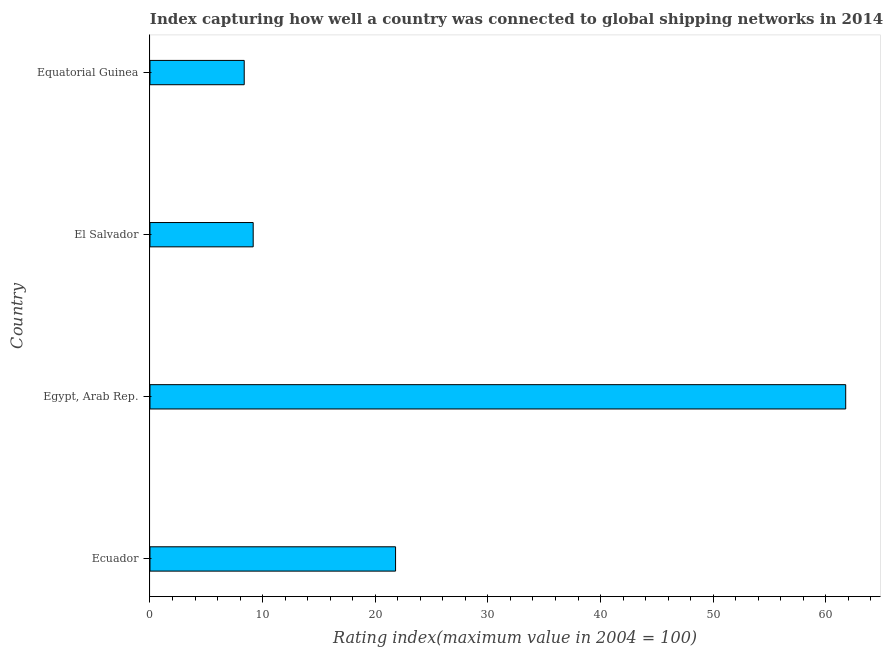What is the title of the graph?
Your response must be concise. Index capturing how well a country was connected to global shipping networks in 2014. What is the label or title of the X-axis?
Offer a very short reply. Rating index(maximum value in 2004 = 100). What is the label or title of the Y-axis?
Offer a very short reply. Country. What is the liner shipping connectivity index in El Salvador?
Provide a succinct answer. 9.16. Across all countries, what is the maximum liner shipping connectivity index?
Keep it short and to the point. 61.76. Across all countries, what is the minimum liner shipping connectivity index?
Your response must be concise. 8.36. In which country was the liner shipping connectivity index maximum?
Give a very brief answer. Egypt, Arab Rep. In which country was the liner shipping connectivity index minimum?
Keep it short and to the point. Equatorial Guinea. What is the sum of the liner shipping connectivity index?
Offer a terse response. 101.09. What is the difference between the liner shipping connectivity index in Ecuador and Egypt, Arab Rep.?
Ensure brevity in your answer.  -39.96. What is the average liner shipping connectivity index per country?
Your answer should be very brief. 25.27. What is the median liner shipping connectivity index?
Offer a very short reply. 15.48. What is the ratio of the liner shipping connectivity index in Ecuador to that in El Salvador?
Provide a succinct answer. 2.38. Is the difference between the liner shipping connectivity index in Ecuador and Equatorial Guinea greater than the difference between any two countries?
Ensure brevity in your answer.  No. What is the difference between the highest and the second highest liner shipping connectivity index?
Offer a terse response. 39.96. What is the difference between the highest and the lowest liner shipping connectivity index?
Your answer should be very brief. 53.4. In how many countries, is the liner shipping connectivity index greater than the average liner shipping connectivity index taken over all countries?
Give a very brief answer. 1. How many countries are there in the graph?
Provide a short and direct response. 4. What is the Rating index(maximum value in 2004 = 100) in Ecuador?
Offer a very short reply. 21.8. What is the Rating index(maximum value in 2004 = 100) in Egypt, Arab Rep.?
Make the answer very short. 61.76. What is the Rating index(maximum value in 2004 = 100) in El Salvador?
Your response must be concise. 9.16. What is the Rating index(maximum value in 2004 = 100) of Equatorial Guinea?
Provide a succinct answer. 8.36. What is the difference between the Rating index(maximum value in 2004 = 100) in Ecuador and Egypt, Arab Rep.?
Ensure brevity in your answer.  -39.96. What is the difference between the Rating index(maximum value in 2004 = 100) in Ecuador and El Salvador?
Your response must be concise. 12.64. What is the difference between the Rating index(maximum value in 2004 = 100) in Ecuador and Equatorial Guinea?
Offer a very short reply. 13.44. What is the difference between the Rating index(maximum value in 2004 = 100) in Egypt, Arab Rep. and El Salvador?
Ensure brevity in your answer.  52.6. What is the difference between the Rating index(maximum value in 2004 = 100) in Egypt, Arab Rep. and Equatorial Guinea?
Offer a very short reply. 53.4. What is the difference between the Rating index(maximum value in 2004 = 100) in El Salvador and Equatorial Guinea?
Provide a short and direct response. 0.8. What is the ratio of the Rating index(maximum value in 2004 = 100) in Ecuador to that in Egypt, Arab Rep.?
Provide a short and direct response. 0.35. What is the ratio of the Rating index(maximum value in 2004 = 100) in Ecuador to that in El Salvador?
Provide a succinct answer. 2.38. What is the ratio of the Rating index(maximum value in 2004 = 100) in Ecuador to that in Equatorial Guinea?
Ensure brevity in your answer.  2.61. What is the ratio of the Rating index(maximum value in 2004 = 100) in Egypt, Arab Rep. to that in El Salvador?
Make the answer very short. 6.74. What is the ratio of the Rating index(maximum value in 2004 = 100) in Egypt, Arab Rep. to that in Equatorial Guinea?
Keep it short and to the point. 7.38. What is the ratio of the Rating index(maximum value in 2004 = 100) in El Salvador to that in Equatorial Guinea?
Offer a very short reply. 1.09. 